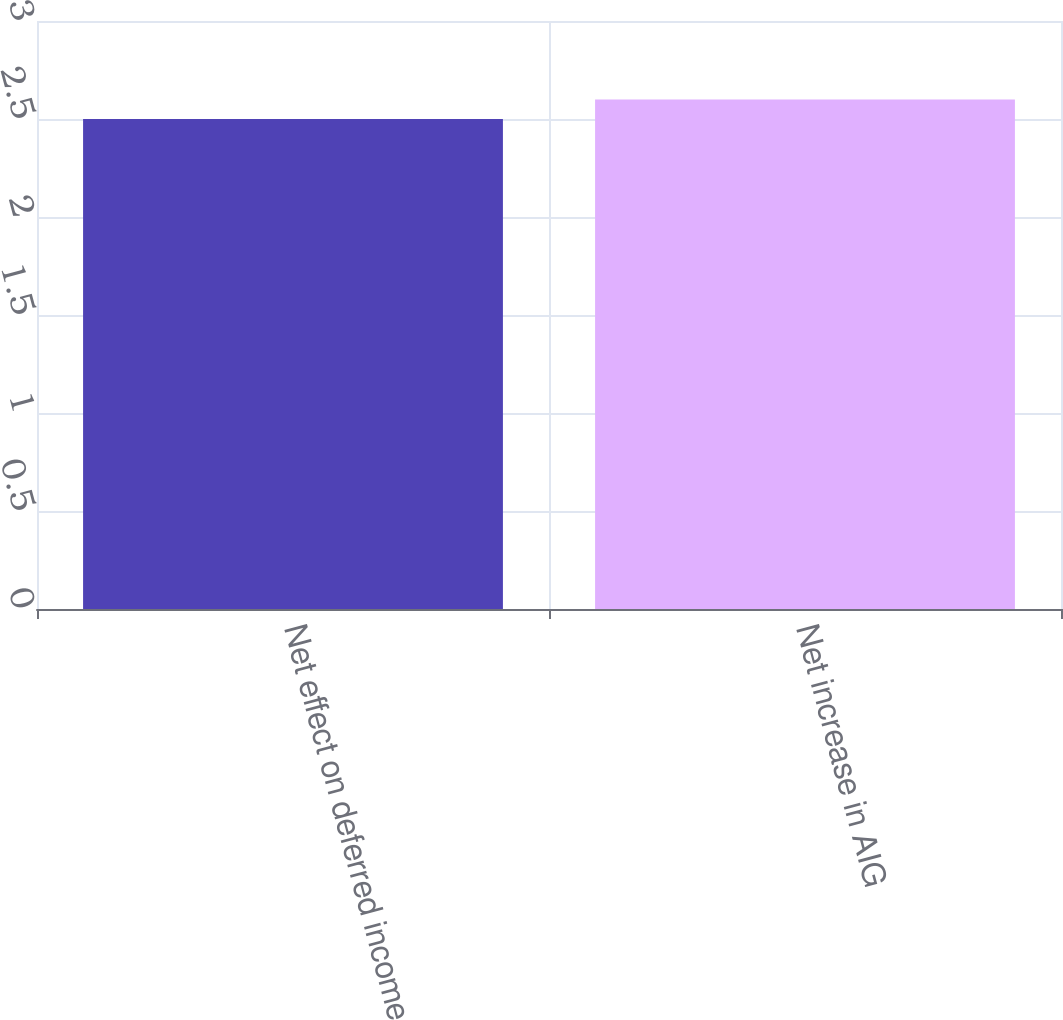Convert chart. <chart><loc_0><loc_0><loc_500><loc_500><bar_chart><fcel>Net effect on deferred income<fcel>Net increase in AIG<nl><fcel>2.5<fcel>2.6<nl></chart> 